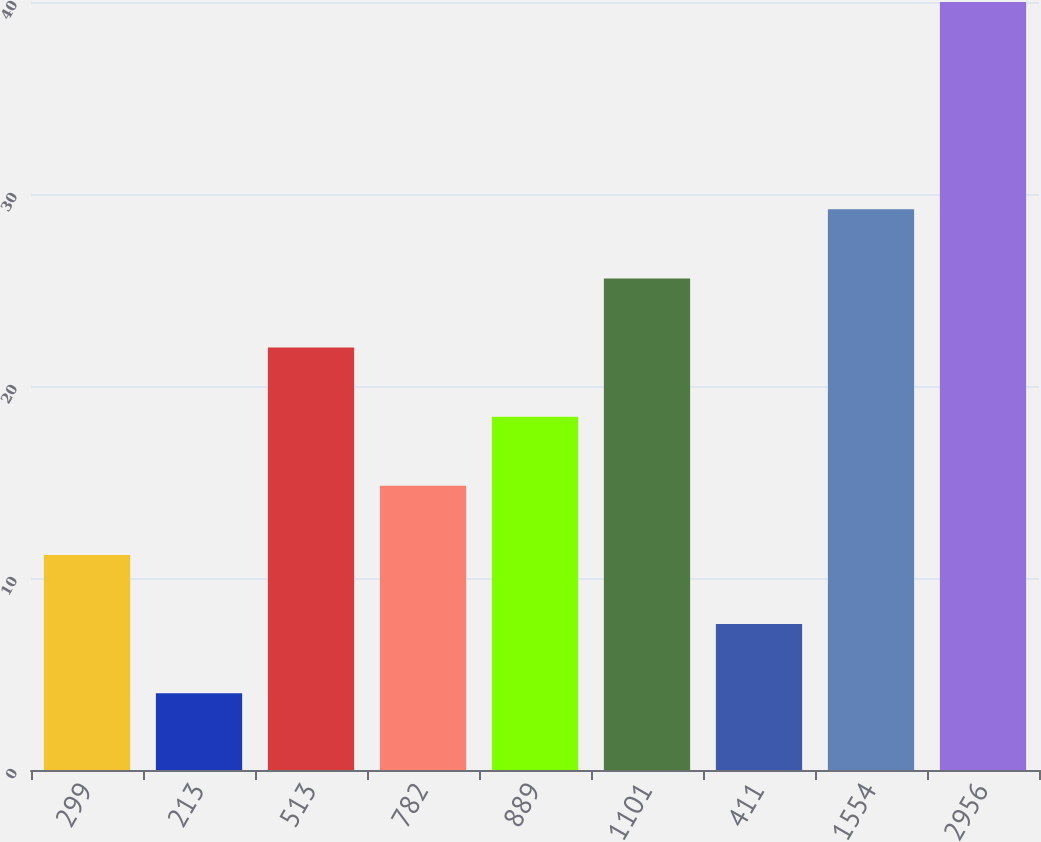Convert chart to OTSL. <chart><loc_0><loc_0><loc_500><loc_500><bar_chart><fcel>299<fcel>213<fcel>513<fcel>782<fcel>889<fcel>1101<fcel>411<fcel>1554<fcel>2956<nl><fcel>11.2<fcel>4<fcel>22<fcel>14.8<fcel>18.4<fcel>25.6<fcel>7.6<fcel>29.2<fcel>40<nl></chart> 